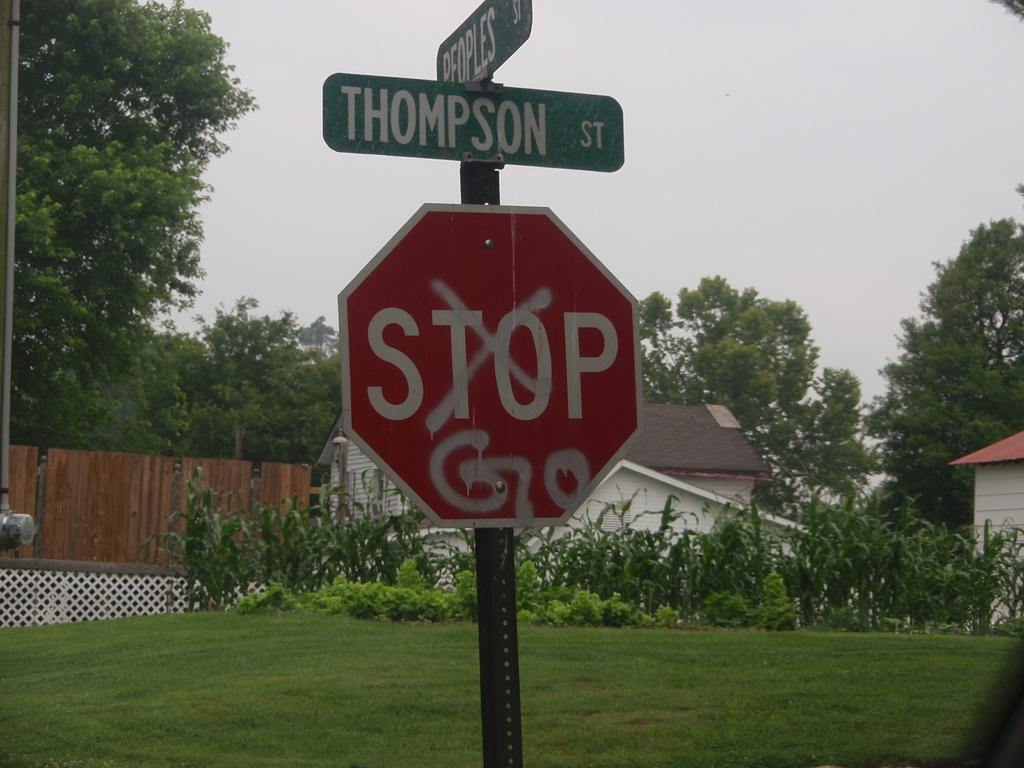<image>
Relay a brief, clear account of the picture shown. a red stop sign with the street signs on top 